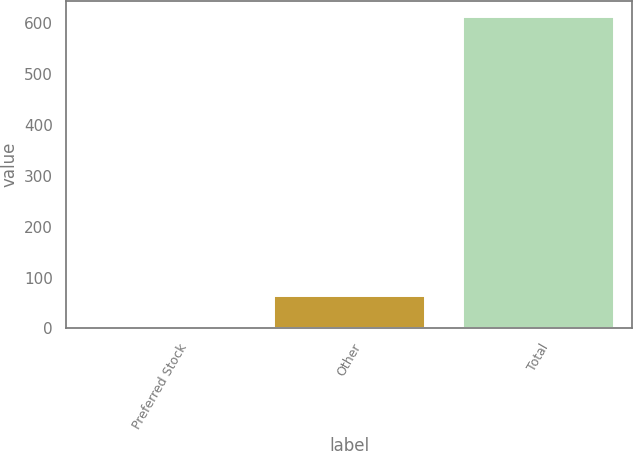<chart> <loc_0><loc_0><loc_500><loc_500><bar_chart><fcel>Preferred Stock<fcel>Other<fcel>Total<nl><fcel>2<fcel>63.1<fcel>613<nl></chart> 